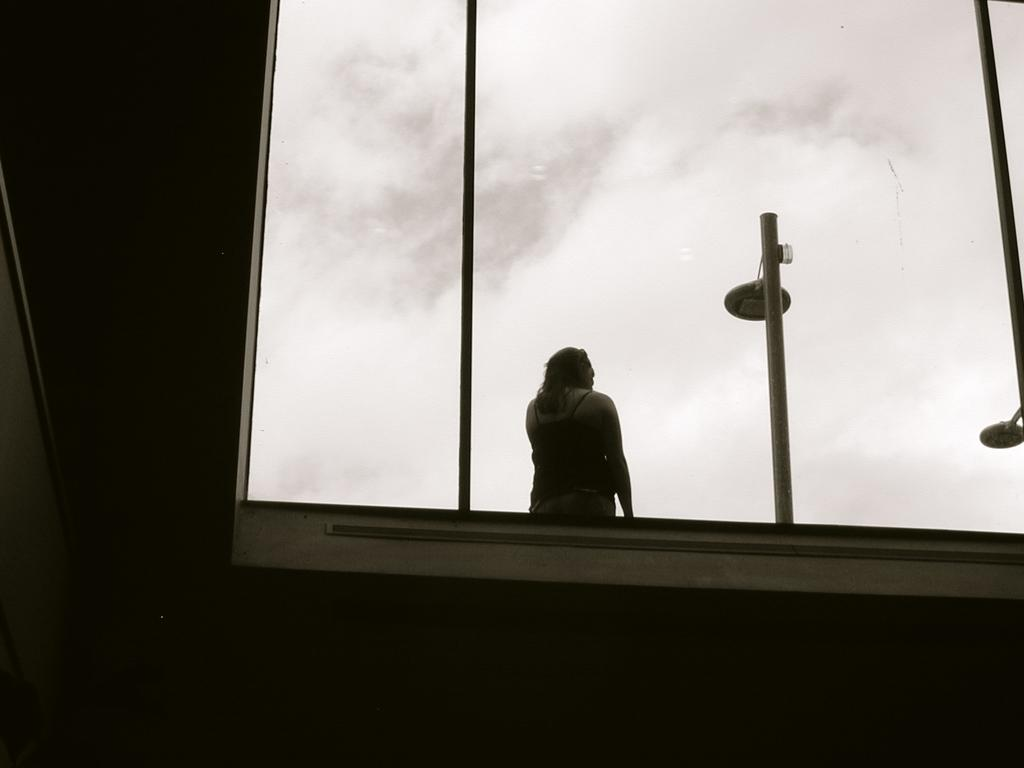What is located at the bottom of the image? There is a roof at the bottom of the image. Who or what is in the middle of the image? There is a person in the middle of the image. What can be seen in the background of the image? The sky with clouds is visible in the background. What else is present in the image besides the roof, person, and sky? There are poles in the image. Can you hear the crow laughing in the image? There is no crow or laughter present in the image. What type of bird can be seen flying in the image? There is no bird visible in the image. 